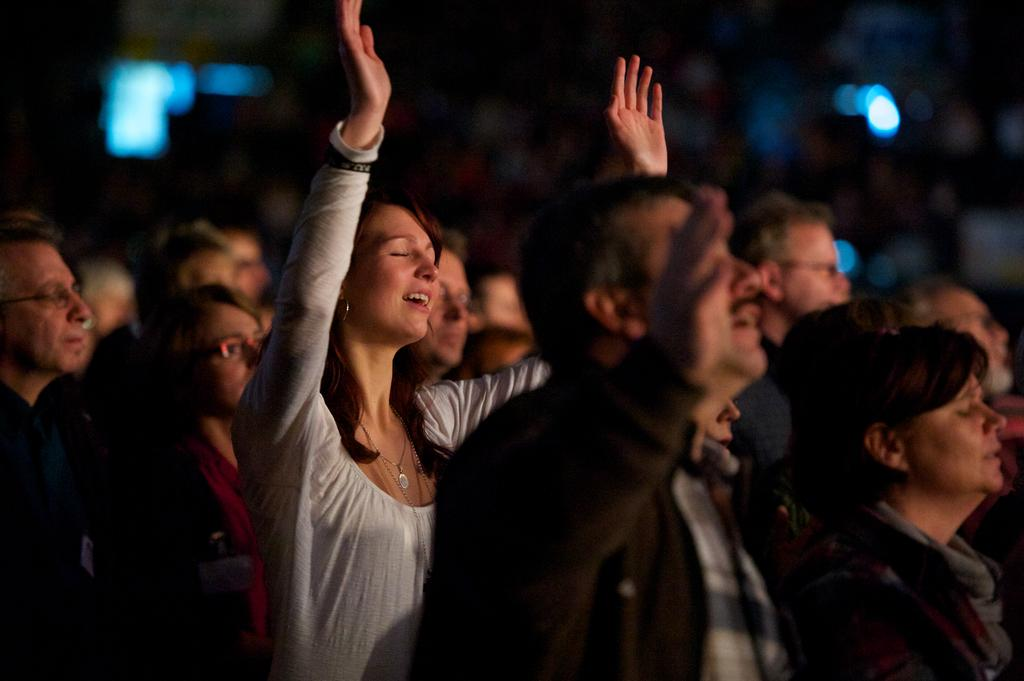What is the main focus of the image? The main focus of the image is the people in the center. Can you describe the background of the image? The background of the image is blurred. What is the size of the oranges in the image? There are no oranges present in the image, so it is not possible to determine their size. 